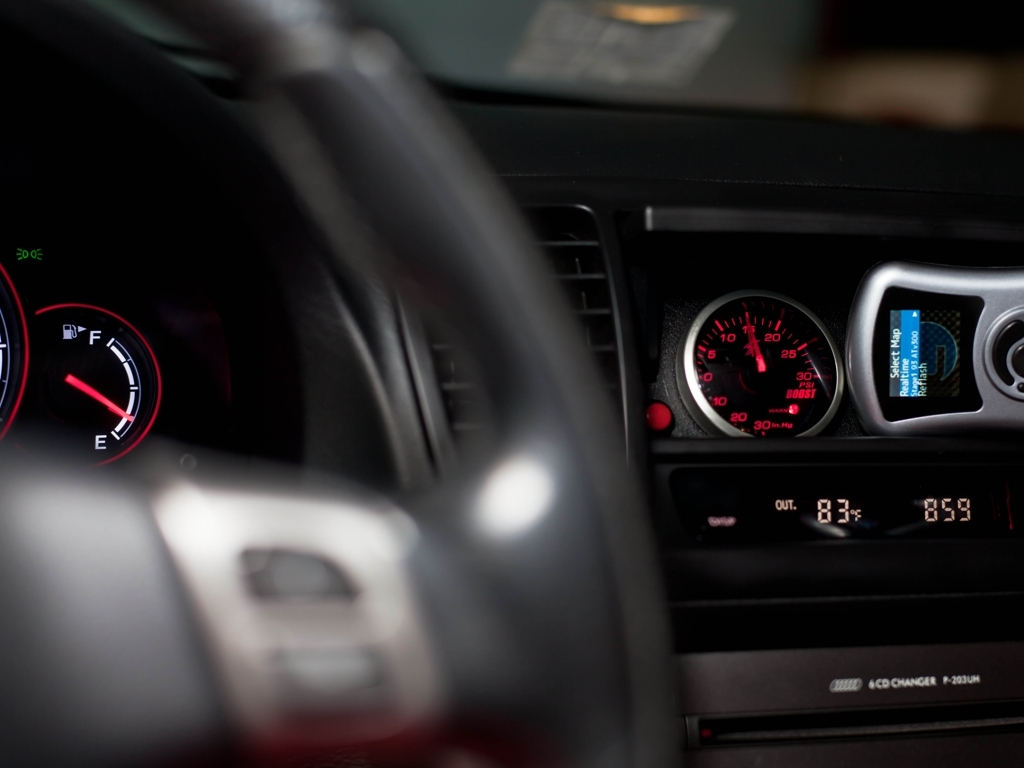If one were to speculate, what might be the reason for the photo's focus on the gauges? It's possible that the photo's focus on the fuel gauge and speedometer is meant to highlight the car's stationary status while having nearly a full tank of gas. This could be relevant in a number of scenarios, such as showcasing a new car, highlighting the efficiency after a long trip, or simply capturing the moment before starting a journey. 